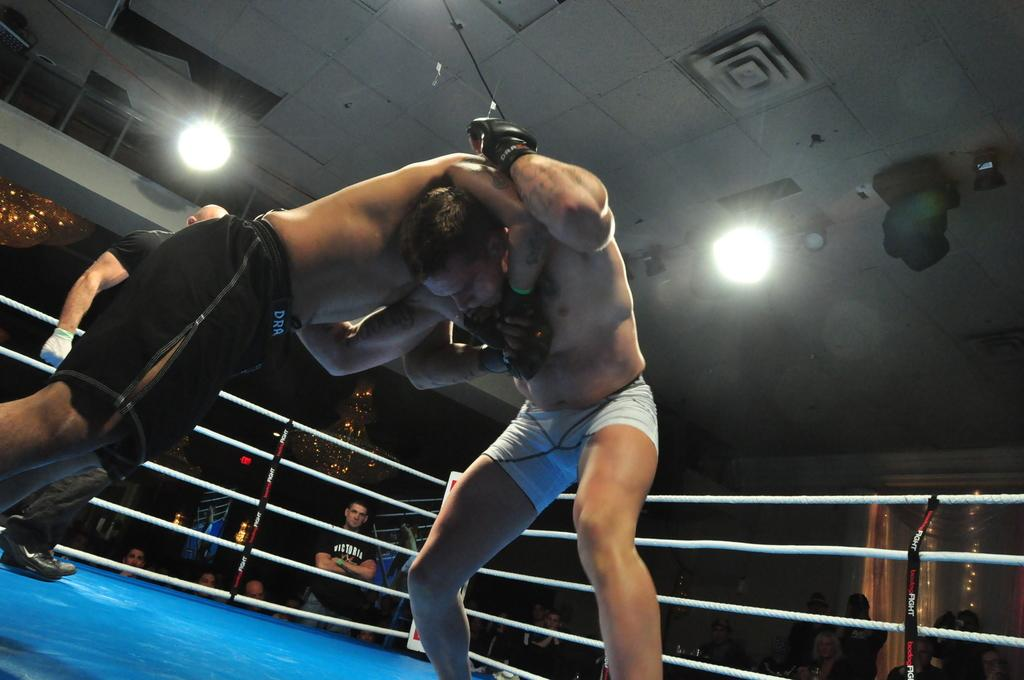How many people are in the image? There are people in the image. What are the two people in the image doing? Two people are fighting in a ring. What is the structure of the ring? The ring has ropes. What type of lighting is visible in the image? There are ceiling lights visible. What device is used for amplifying sound in the image? There is a speaker in the image. What type of architectural feature is visible in the image? There is a wall in the image. What type of scientific experiment is being conducted in the image? There is no scientific experiment present in the image; it features people fighting in a ring. What type of yoke is being used by the people in the image? There is no yoke present in the image; it features people fighting in a ring. 